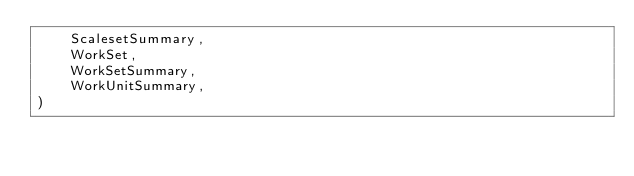<code> <loc_0><loc_0><loc_500><loc_500><_Python_>    ScalesetSummary,
    WorkSet,
    WorkSetSummary,
    WorkUnitSummary,
)</code> 